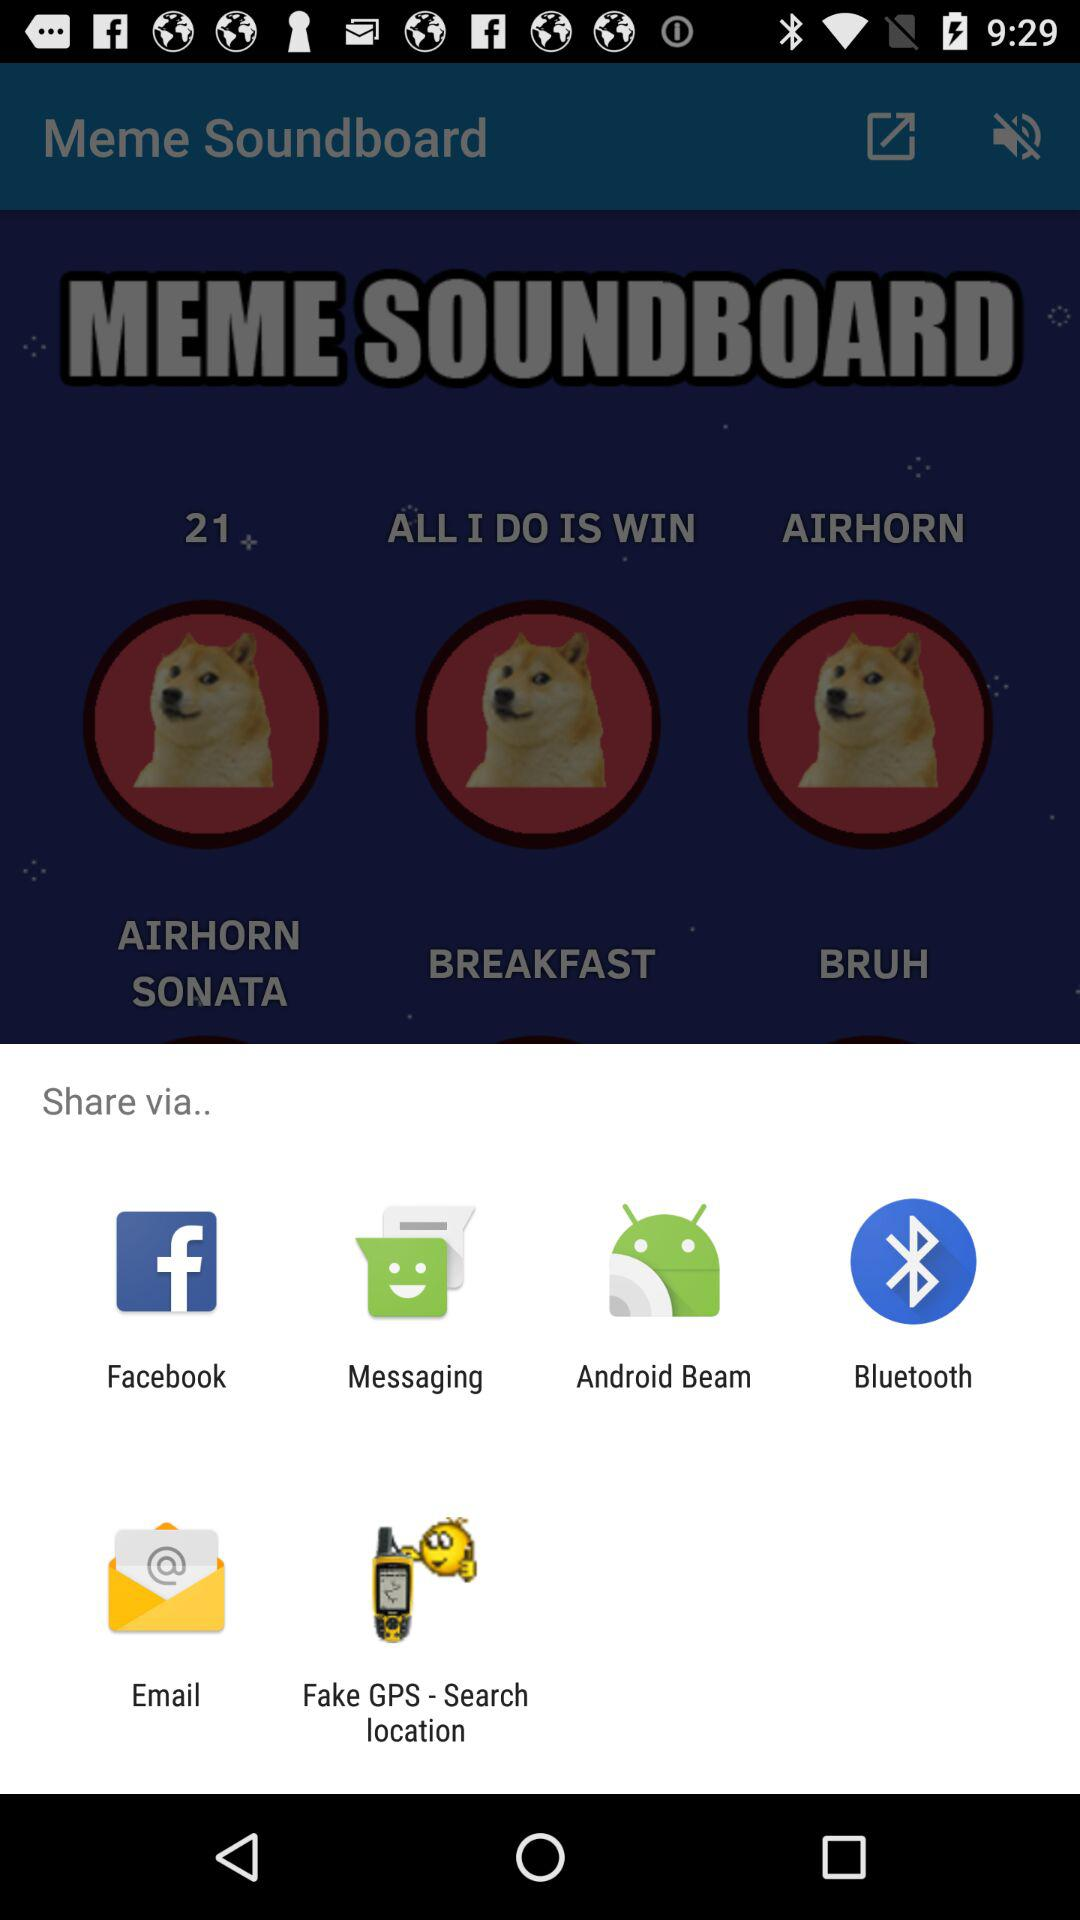What are the sharing options? The sharing options are "Facebook", "Messaging", "Android Beam", "Bluetooth", "Email" and "Fake GPS - Search location". 